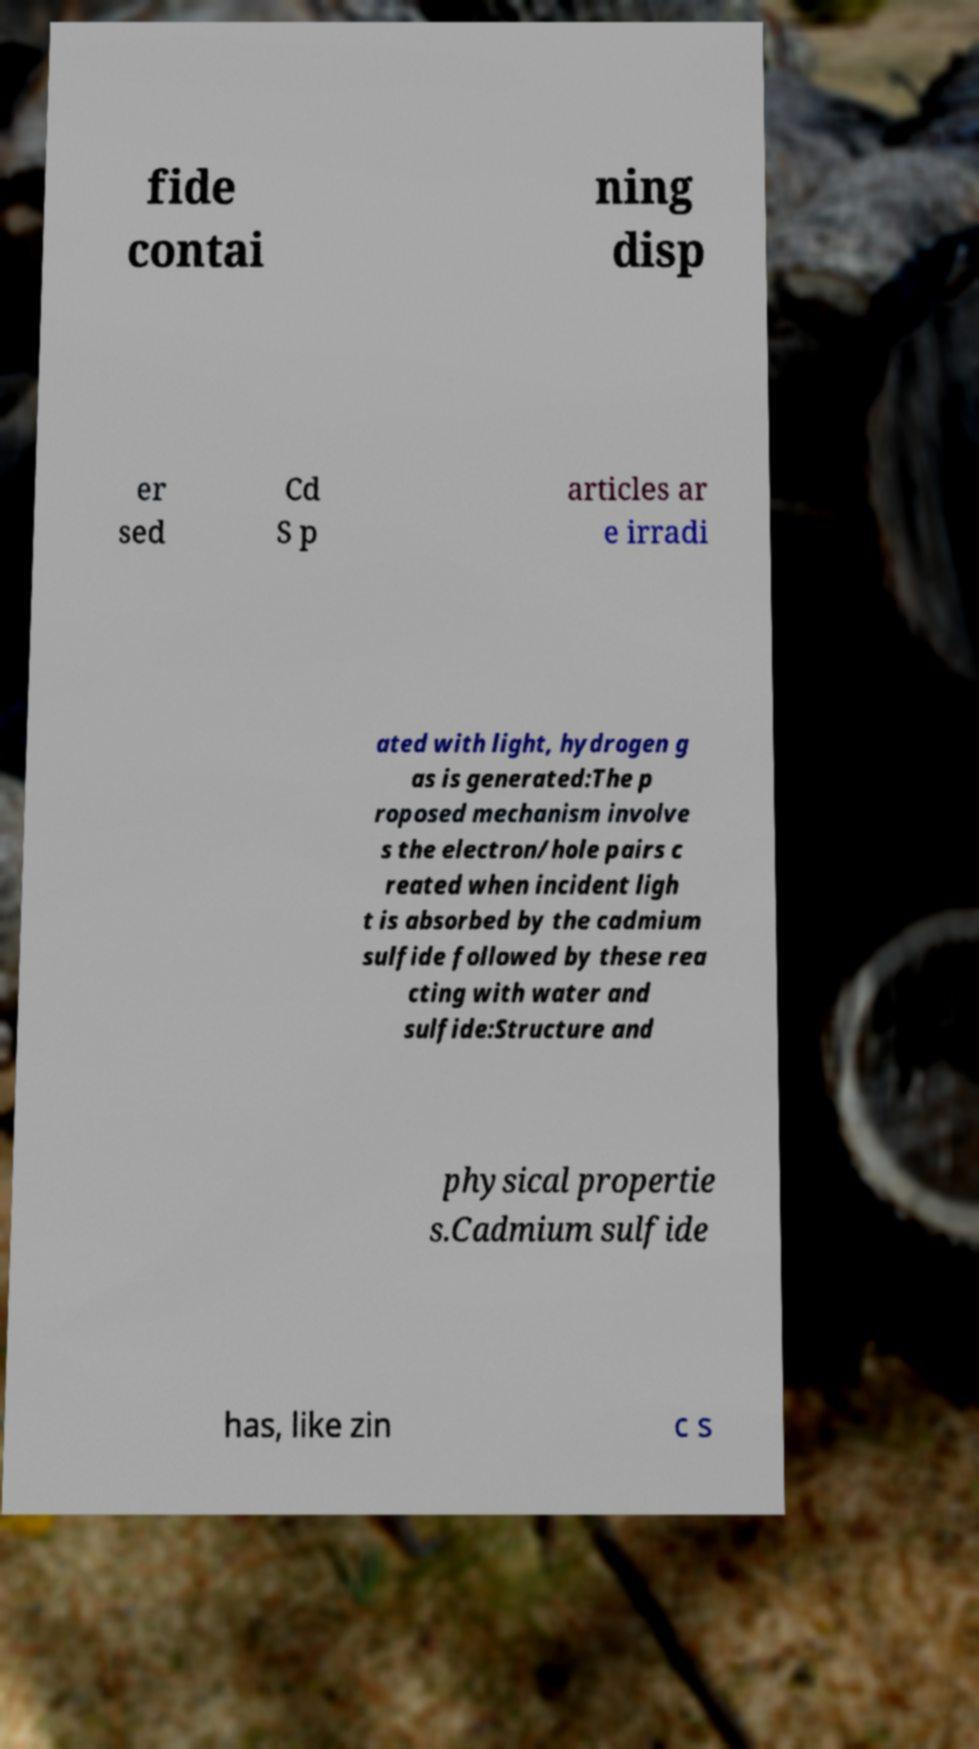What messages or text are displayed in this image? I need them in a readable, typed format. fide contai ning disp er sed Cd S p articles ar e irradi ated with light, hydrogen g as is generated:The p roposed mechanism involve s the electron/hole pairs c reated when incident ligh t is absorbed by the cadmium sulfide followed by these rea cting with water and sulfide:Structure and physical propertie s.Cadmium sulfide has, like zin c s 